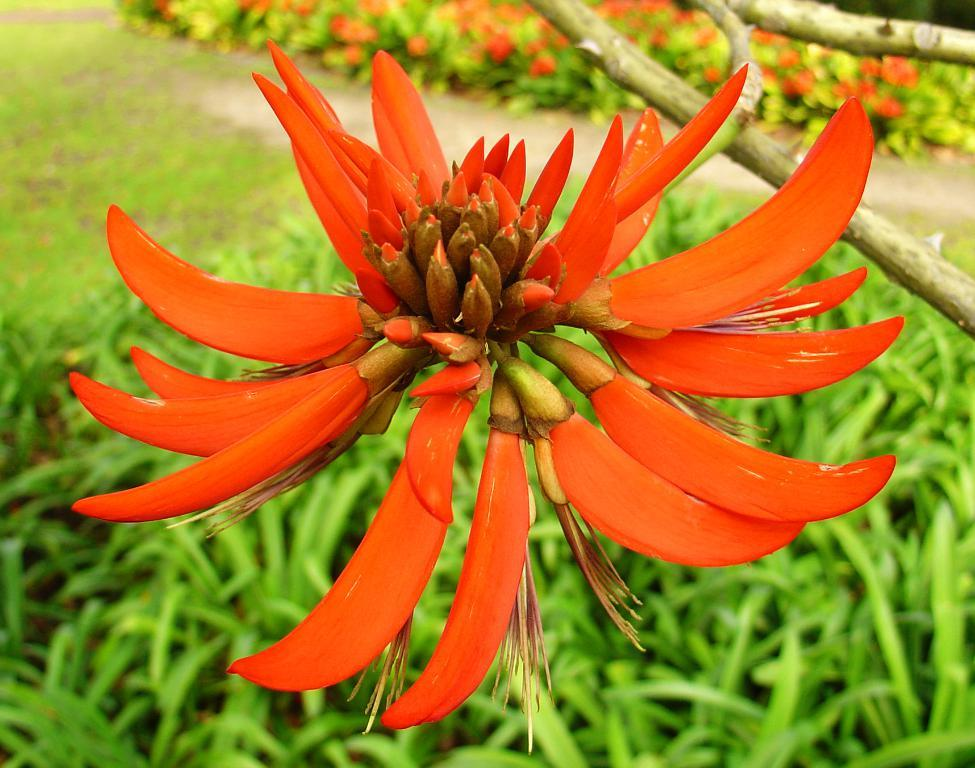What type of plant can be seen in the image? There is a flower in the image, and the stem part of a plant is visible. What type of vegetation is present in the image? There is grass in the image. What discovery was made in the image? There is no indication of a discovery being made in the image. What does the flower look like in the image? The flower is not described in detail in the provided facts, so it is not possible to answer this question definitively. 